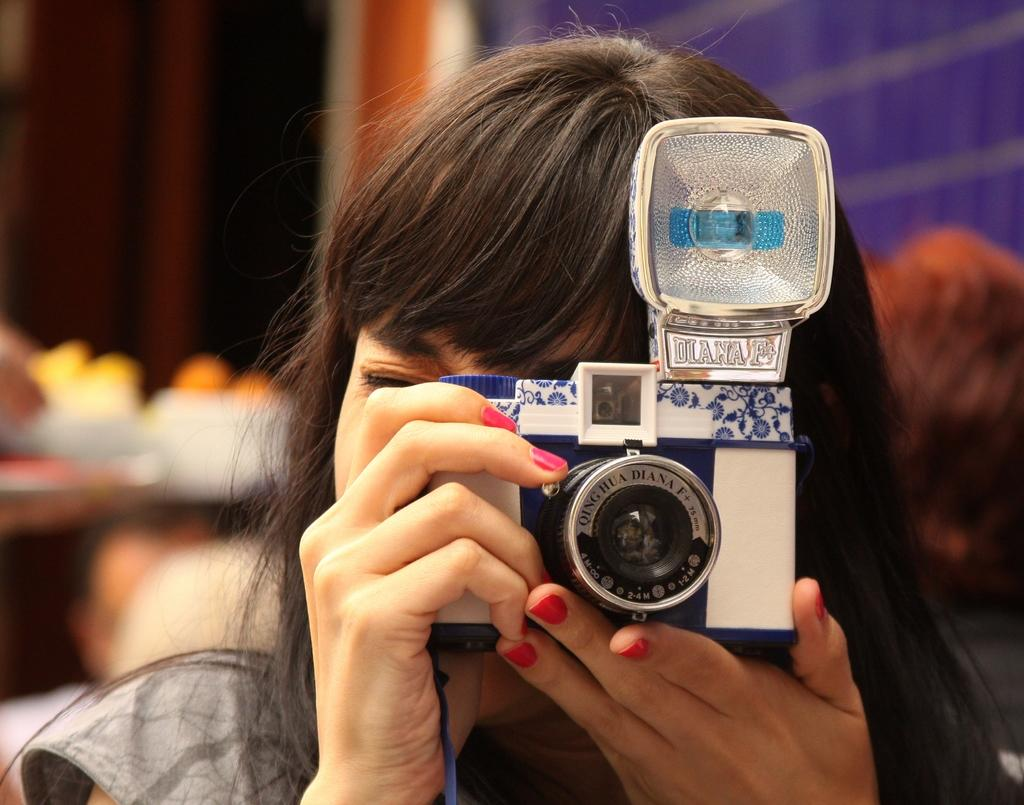<image>
Write a terse but informative summary of the picture. A woman is using a QING HUA DIANA F+ 75 mm camera. 